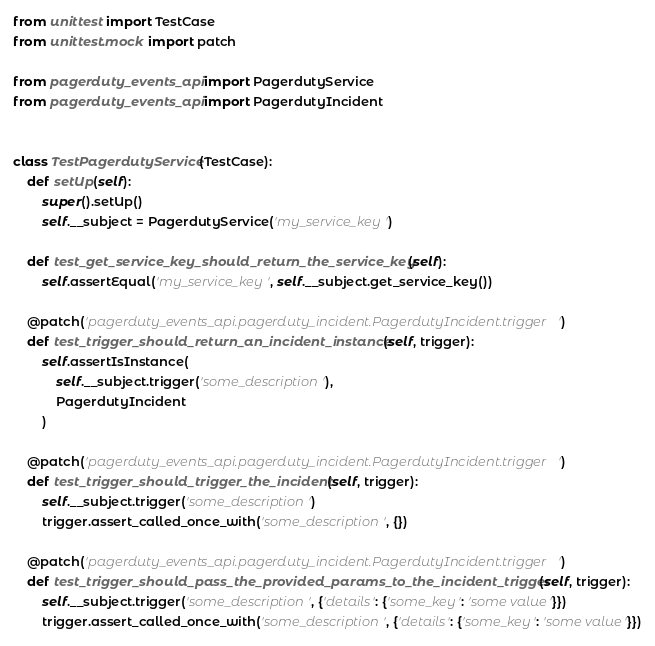Convert code to text. <code><loc_0><loc_0><loc_500><loc_500><_Python_>from unittest import TestCase
from unittest.mock import patch

from pagerduty_events_api import PagerdutyService
from pagerduty_events_api import PagerdutyIncident


class TestPagerdutyService(TestCase):
    def setUp(self):
        super().setUp()
        self.__subject = PagerdutyService('my_service_key')

    def test_get_service_key_should_return_the_service_key(self):
        self.assertEqual('my_service_key', self.__subject.get_service_key())

    @patch('pagerduty_events_api.pagerduty_incident.PagerdutyIncident.trigger')
    def test_trigger_should_return_an_incident_instance(self, trigger):
        self.assertIsInstance(
            self.__subject.trigger('some_description'),
            PagerdutyIncident
        )

    @patch('pagerduty_events_api.pagerduty_incident.PagerdutyIncident.trigger')
    def test_trigger_should_trigger_the_incident(self, trigger):
        self.__subject.trigger('some_description')
        trigger.assert_called_once_with('some_description', {})

    @patch('pagerduty_events_api.pagerduty_incident.PagerdutyIncident.trigger')
    def test_trigger_should_pass_the_provided_params_to_the_incident_trigger(self, trigger):
        self.__subject.trigger('some_description', {'details': {'some_key': 'some value'}})
        trigger.assert_called_once_with('some_description', {'details': {'some_key': 'some value'}})
</code> 